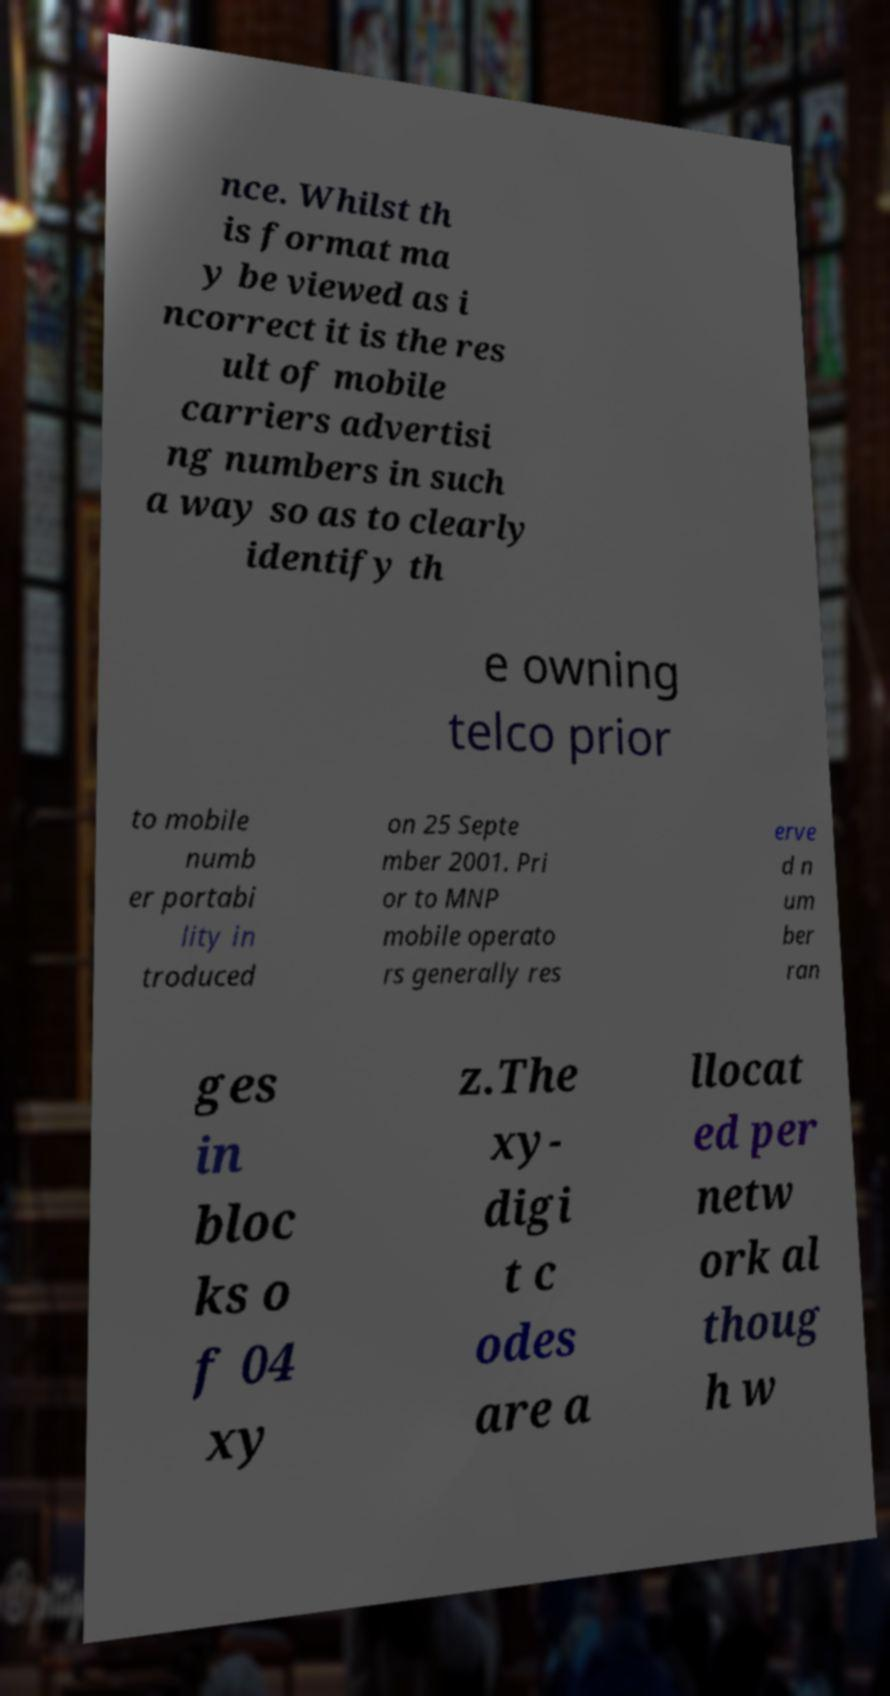I need the written content from this picture converted into text. Can you do that? nce. Whilst th is format ma y be viewed as i ncorrect it is the res ult of mobile carriers advertisi ng numbers in such a way so as to clearly identify th e owning telco prior to mobile numb er portabi lity in troduced on 25 Septe mber 2001. Pri or to MNP mobile operato rs generally res erve d n um ber ran ges in bloc ks o f 04 xy z.The xy- digi t c odes are a llocat ed per netw ork al thoug h w 